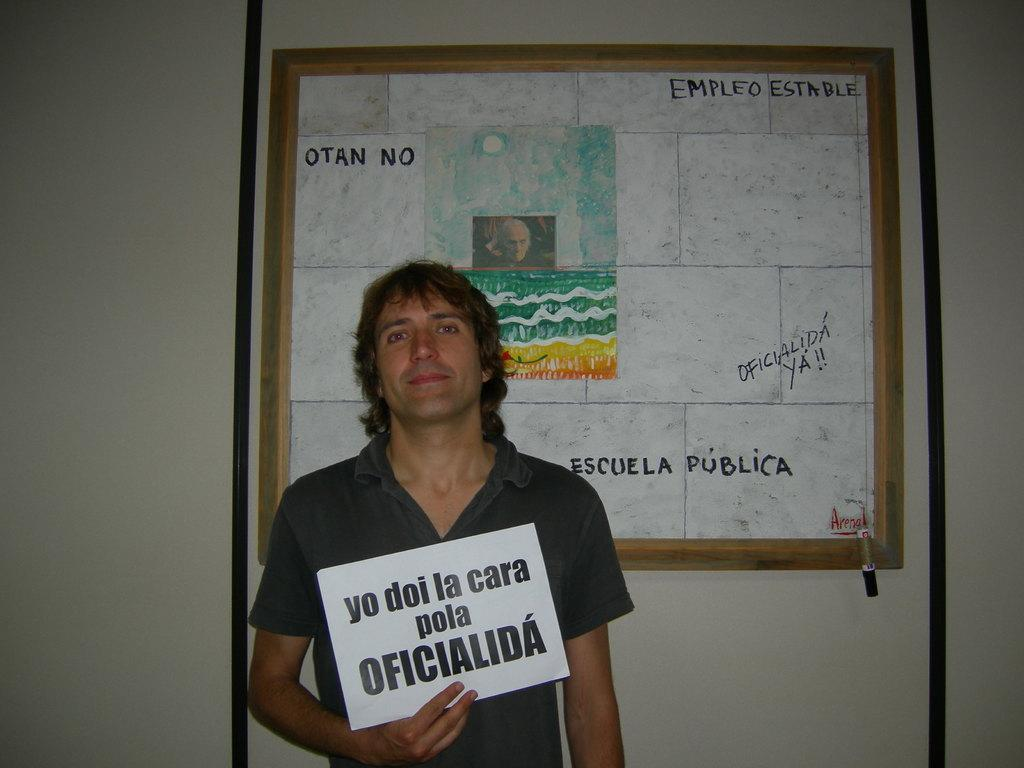What is the person in the image wearing? The person is wearing a gray t-shirt. What is the person's facial expression in the image? The person is smiling. What is the person's posture in the image? The person is standing. What is the person holding in the image? The person is holding a white hoarding. What can be seen in the background of the image? There is a board in the background of the image. How is the board positioned in the image? The board is attached to a wall. What type of baseball is the person holding in the image? There is no baseball present in the image; the person is holding a white hoarding. Can you describe the person's tongue in the image? There is no mention of the person's tongue in the image, so it cannot be described. 